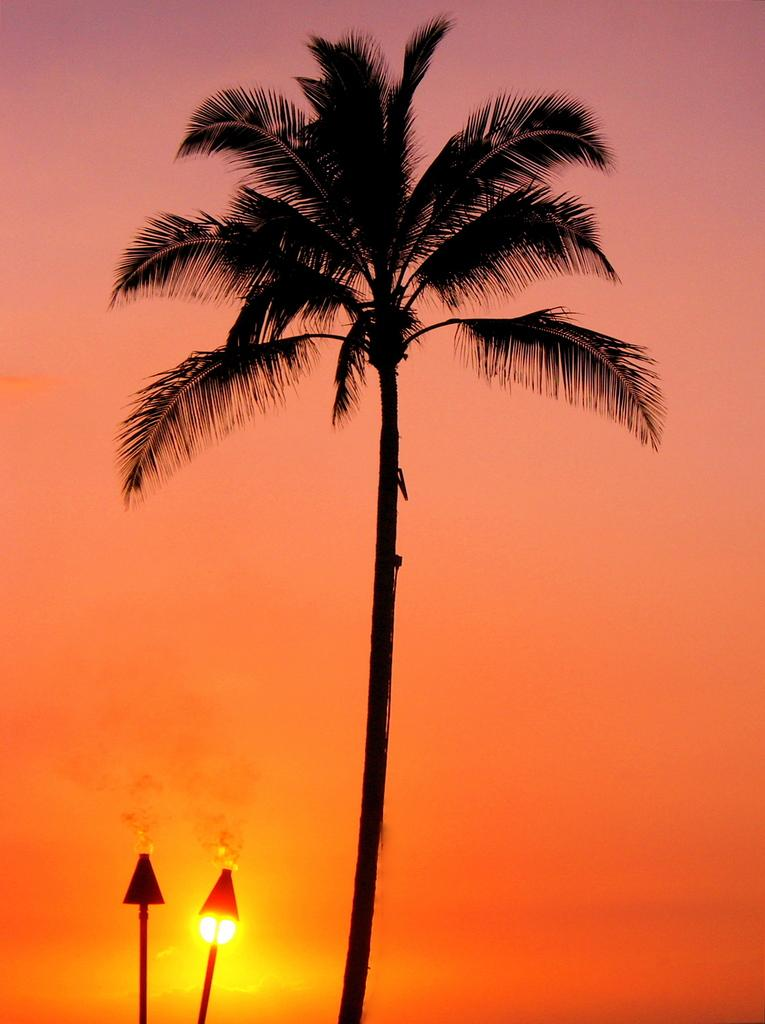What can be seen in the background of the image? The sky is visible in the background of the image. What celestial body is visible in the sky? The sun is visible in the sky. What are the main subjects in the image? There are objects in the image, and a tree is the main highlight. What type of apparel are the brothers wearing in the image? There are no brothers or apparel present in the image. How many scissors can be seen cutting the tree in the image? There are no scissors or tree-cutting activity depicted in the image. 